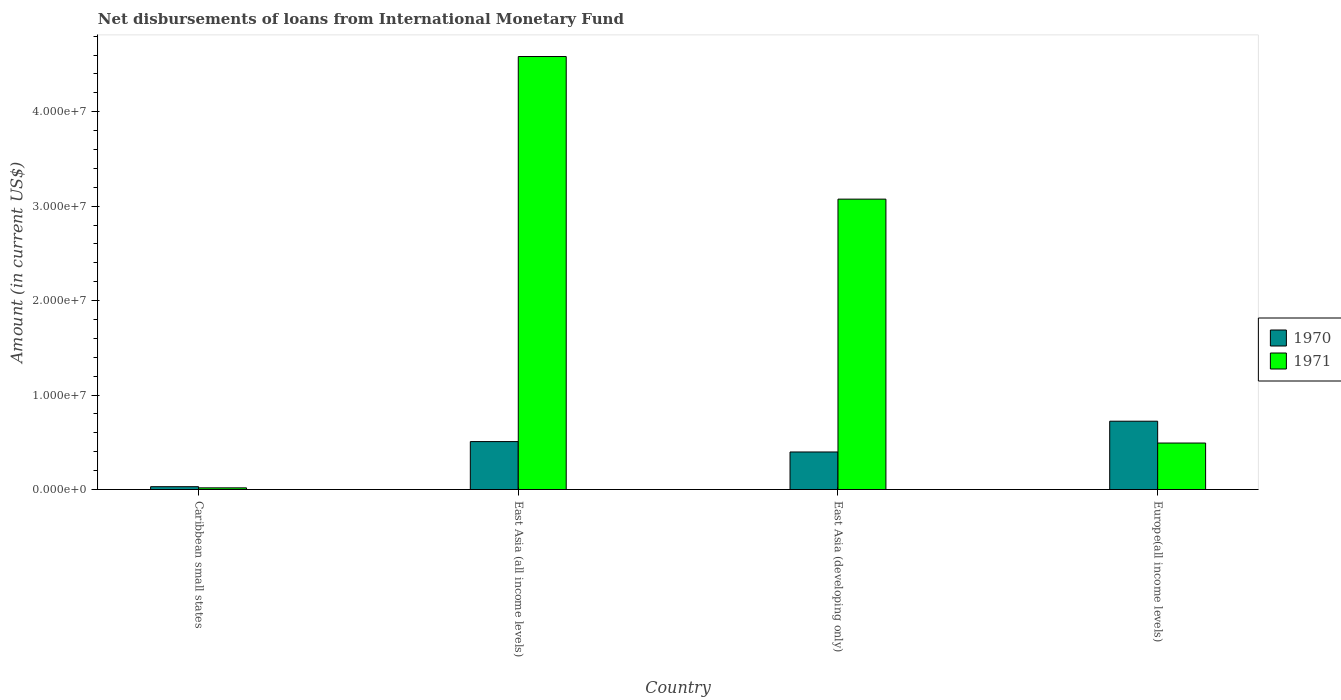How many different coloured bars are there?
Your answer should be very brief. 2. How many groups of bars are there?
Ensure brevity in your answer.  4. Are the number of bars on each tick of the X-axis equal?
Offer a very short reply. Yes. How many bars are there on the 4th tick from the right?
Offer a very short reply. 2. What is the label of the 4th group of bars from the left?
Provide a short and direct response. Europe(all income levels). What is the amount of loans disbursed in 1971 in East Asia (all income levels)?
Make the answer very short. 4.58e+07. Across all countries, what is the maximum amount of loans disbursed in 1970?
Make the answer very short. 7.23e+06. Across all countries, what is the minimum amount of loans disbursed in 1971?
Offer a terse response. 1.76e+05. In which country was the amount of loans disbursed in 1970 maximum?
Keep it short and to the point. Europe(all income levels). In which country was the amount of loans disbursed in 1971 minimum?
Offer a terse response. Caribbean small states. What is the total amount of loans disbursed in 1971 in the graph?
Offer a very short reply. 8.17e+07. What is the difference between the amount of loans disbursed in 1971 in Caribbean small states and that in Europe(all income levels)?
Make the answer very short. -4.75e+06. What is the difference between the amount of loans disbursed in 1971 in Caribbean small states and the amount of loans disbursed in 1970 in East Asia (all income levels)?
Make the answer very short. -4.90e+06. What is the average amount of loans disbursed in 1971 per country?
Provide a succinct answer. 2.04e+07. What is the difference between the amount of loans disbursed of/in 1970 and amount of loans disbursed of/in 1971 in East Asia (all income levels)?
Offer a terse response. -4.08e+07. In how many countries, is the amount of loans disbursed in 1971 greater than 34000000 US$?
Make the answer very short. 1. What is the ratio of the amount of loans disbursed in 1971 in Caribbean small states to that in Europe(all income levels)?
Your answer should be compact. 0.04. Is the amount of loans disbursed in 1971 in East Asia (developing only) less than that in Europe(all income levels)?
Make the answer very short. No. Is the difference between the amount of loans disbursed in 1970 in East Asia (all income levels) and East Asia (developing only) greater than the difference between the amount of loans disbursed in 1971 in East Asia (all income levels) and East Asia (developing only)?
Ensure brevity in your answer.  No. What is the difference between the highest and the second highest amount of loans disbursed in 1970?
Your answer should be very brief. 2.16e+06. What is the difference between the highest and the lowest amount of loans disbursed in 1971?
Ensure brevity in your answer.  4.57e+07. In how many countries, is the amount of loans disbursed in 1971 greater than the average amount of loans disbursed in 1971 taken over all countries?
Give a very brief answer. 2. How many bars are there?
Provide a short and direct response. 8. How many countries are there in the graph?
Your answer should be very brief. 4. What is the difference between two consecutive major ticks on the Y-axis?
Provide a short and direct response. 1.00e+07. Are the values on the major ticks of Y-axis written in scientific E-notation?
Offer a very short reply. Yes. Does the graph contain any zero values?
Offer a terse response. No. Where does the legend appear in the graph?
Make the answer very short. Center right. How are the legend labels stacked?
Make the answer very short. Vertical. What is the title of the graph?
Offer a very short reply. Net disbursements of loans from International Monetary Fund. Does "2005" appear as one of the legend labels in the graph?
Keep it short and to the point. No. What is the Amount (in current US$) in 1970 in Caribbean small states?
Your answer should be very brief. 2.99e+05. What is the Amount (in current US$) in 1971 in Caribbean small states?
Make the answer very short. 1.76e+05. What is the Amount (in current US$) of 1970 in East Asia (all income levels)?
Offer a very short reply. 5.08e+06. What is the Amount (in current US$) in 1971 in East Asia (all income levels)?
Your response must be concise. 4.58e+07. What is the Amount (in current US$) of 1970 in East Asia (developing only)?
Provide a succinct answer. 3.98e+06. What is the Amount (in current US$) of 1971 in East Asia (developing only)?
Offer a very short reply. 3.07e+07. What is the Amount (in current US$) of 1970 in Europe(all income levels)?
Provide a succinct answer. 7.23e+06. What is the Amount (in current US$) in 1971 in Europe(all income levels)?
Your answer should be compact. 4.92e+06. Across all countries, what is the maximum Amount (in current US$) in 1970?
Offer a terse response. 7.23e+06. Across all countries, what is the maximum Amount (in current US$) of 1971?
Keep it short and to the point. 4.58e+07. Across all countries, what is the minimum Amount (in current US$) in 1970?
Provide a succinct answer. 2.99e+05. Across all countries, what is the minimum Amount (in current US$) in 1971?
Give a very brief answer. 1.76e+05. What is the total Amount (in current US$) of 1970 in the graph?
Your response must be concise. 1.66e+07. What is the total Amount (in current US$) of 1971 in the graph?
Keep it short and to the point. 8.17e+07. What is the difference between the Amount (in current US$) in 1970 in Caribbean small states and that in East Asia (all income levels)?
Your response must be concise. -4.78e+06. What is the difference between the Amount (in current US$) in 1971 in Caribbean small states and that in East Asia (all income levels)?
Give a very brief answer. -4.57e+07. What is the difference between the Amount (in current US$) in 1970 in Caribbean small states and that in East Asia (developing only)?
Make the answer very short. -3.68e+06. What is the difference between the Amount (in current US$) of 1971 in Caribbean small states and that in East Asia (developing only)?
Give a very brief answer. -3.06e+07. What is the difference between the Amount (in current US$) of 1970 in Caribbean small states and that in Europe(all income levels)?
Your answer should be compact. -6.93e+06. What is the difference between the Amount (in current US$) in 1971 in Caribbean small states and that in Europe(all income levels)?
Give a very brief answer. -4.75e+06. What is the difference between the Amount (in current US$) of 1970 in East Asia (all income levels) and that in East Asia (developing only)?
Offer a very short reply. 1.10e+06. What is the difference between the Amount (in current US$) of 1971 in East Asia (all income levels) and that in East Asia (developing only)?
Your response must be concise. 1.51e+07. What is the difference between the Amount (in current US$) in 1970 in East Asia (all income levels) and that in Europe(all income levels)?
Provide a short and direct response. -2.16e+06. What is the difference between the Amount (in current US$) in 1971 in East Asia (all income levels) and that in Europe(all income levels)?
Keep it short and to the point. 4.09e+07. What is the difference between the Amount (in current US$) in 1970 in East Asia (developing only) and that in Europe(all income levels)?
Ensure brevity in your answer.  -3.26e+06. What is the difference between the Amount (in current US$) of 1971 in East Asia (developing only) and that in Europe(all income levels)?
Provide a succinct answer. 2.58e+07. What is the difference between the Amount (in current US$) of 1970 in Caribbean small states and the Amount (in current US$) of 1971 in East Asia (all income levels)?
Make the answer very short. -4.55e+07. What is the difference between the Amount (in current US$) of 1970 in Caribbean small states and the Amount (in current US$) of 1971 in East Asia (developing only)?
Keep it short and to the point. -3.04e+07. What is the difference between the Amount (in current US$) in 1970 in Caribbean small states and the Amount (in current US$) in 1971 in Europe(all income levels)?
Offer a very short reply. -4.62e+06. What is the difference between the Amount (in current US$) of 1970 in East Asia (all income levels) and the Amount (in current US$) of 1971 in East Asia (developing only)?
Keep it short and to the point. -2.57e+07. What is the difference between the Amount (in current US$) of 1970 in East Asia (all income levels) and the Amount (in current US$) of 1971 in Europe(all income levels)?
Your answer should be compact. 1.54e+05. What is the difference between the Amount (in current US$) of 1970 in East Asia (developing only) and the Amount (in current US$) of 1971 in Europe(all income levels)?
Make the answer very short. -9.46e+05. What is the average Amount (in current US$) in 1970 per country?
Offer a very short reply. 4.15e+06. What is the average Amount (in current US$) of 1971 per country?
Your answer should be very brief. 2.04e+07. What is the difference between the Amount (in current US$) in 1970 and Amount (in current US$) in 1971 in Caribbean small states?
Offer a terse response. 1.23e+05. What is the difference between the Amount (in current US$) in 1970 and Amount (in current US$) in 1971 in East Asia (all income levels)?
Your response must be concise. -4.08e+07. What is the difference between the Amount (in current US$) of 1970 and Amount (in current US$) of 1971 in East Asia (developing only)?
Keep it short and to the point. -2.68e+07. What is the difference between the Amount (in current US$) of 1970 and Amount (in current US$) of 1971 in Europe(all income levels)?
Your answer should be very brief. 2.31e+06. What is the ratio of the Amount (in current US$) in 1970 in Caribbean small states to that in East Asia (all income levels)?
Keep it short and to the point. 0.06. What is the ratio of the Amount (in current US$) in 1971 in Caribbean small states to that in East Asia (all income levels)?
Your answer should be very brief. 0. What is the ratio of the Amount (in current US$) in 1970 in Caribbean small states to that in East Asia (developing only)?
Give a very brief answer. 0.08. What is the ratio of the Amount (in current US$) of 1971 in Caribbean small states to that in East Asia (developing only)?
Give a very brief answer. 0.01. What is the ratio of the Amount (in current US$) in 1970 in Caribbean small states to that in Europe(all income levels)?
Your response must be concise. 0.04. What is the ratio of the Amount (in current US$) in 1971 in Caribbean small states to that in Europe(all income levels)?
Make the answer very short. 0.04. What is the ratio of the Amount (in current US$) in 1970 in East Asia (all income levels) to that in East Asia (developing only)?
Your response must be concise. 1.28. What is the ratio of the Amount (in current US$) in 1971 in East Asia (all income levels) to that in East Asia (developing only)?
Your answer should be very brief. 1.49. What is the ratio of the Amount (in current US$) in 1970 in East Asia (all income levels) to that in Europe(all income levels)?
Offer a very short reply. 0.7. What is the ratio of the Amount (in current US$) of 1971 in East Asia (all income levels) to that in Europe(all income levels)?
Offer a very short reply. 9.31. What is the ratio of the Amount (in current US$) in 1970 in East Asia (developing only) to that in Europe(all income levels)?
Provide a succinct answer. 0.55. What is the ratio of the Amount (in current US$) of 1971 in East Asia (developing only) to that in Europe(all income levels)?
Provide a short and direct response. 6.25. What is the difference between the highest and the second highest Amount (in current US$) in 1970?
Make the answer very short. 2.16e+06. What is the difference between the highest and the second highest Amount (in current US$) in 1971?
Your response must be concise. 1.51e+07. What is the difference between the highest and the lowest Amount (in current US$) in 1970?
Ensure brevity in your answer.  6.93e+06. What is the difference between the highest and the lowest Amount (in current US$) in 1971?
Provide a short and direct response. 4.57e+07. 